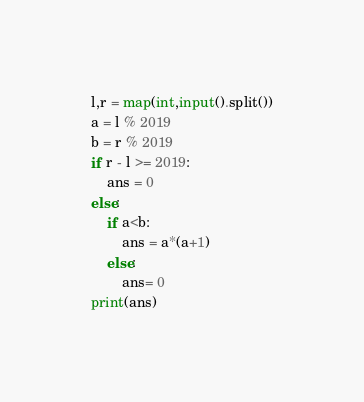Convert code to text. <code><loc_0><loc_0><loc_500><loc_500><_Python_>l,r = map(int,input().split())
a = l % 2019
b = r % 2019
if r - l >= 2019:
    ans = 0
else:
    if a<b:
        ans = a*(a+1)
    else:
        ans= 0
print(ans)
</code> 